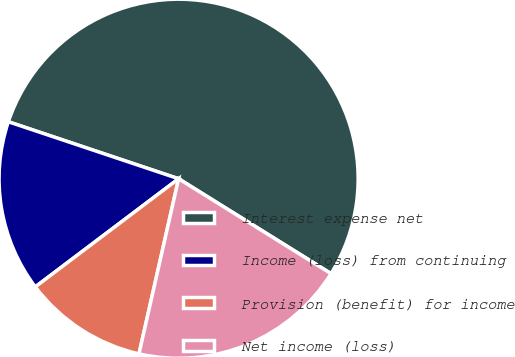Convert chart. <chart><loc_0><loc_0><loc_500><loc_500><pie_chart><fcel>Interest expense net<fcel>Income (loss) from continuing<fcel>Provision (benefit) for income<fcel>Net income (loss)<nl><fcel>53.72%<fcel>15.43%<fcel>11.17%<fcel>19.68%<nl></chart> 